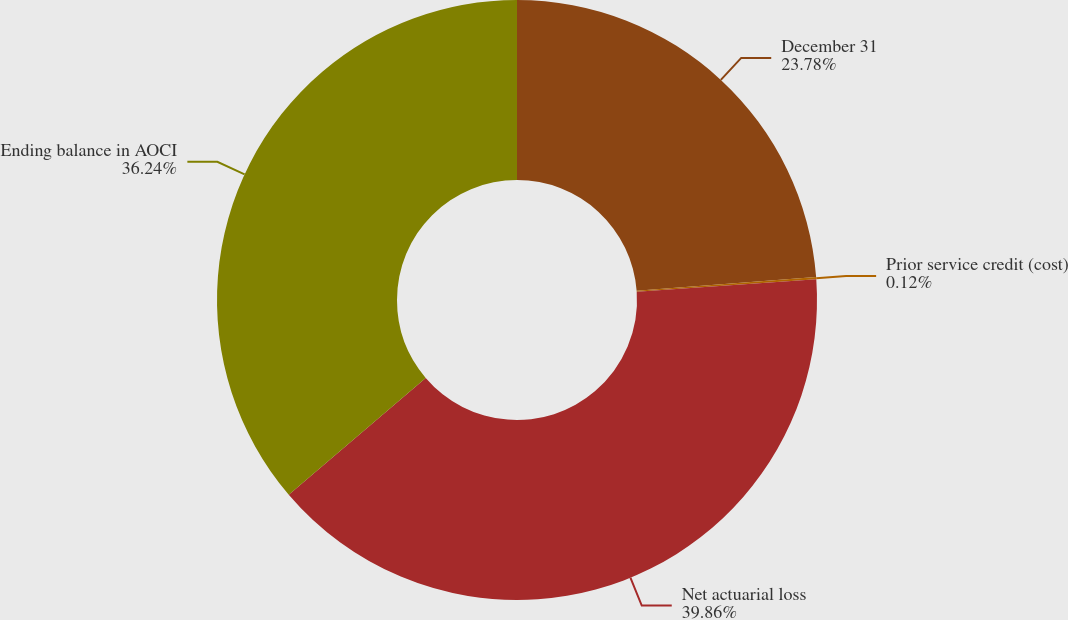Convert chart to OTSL. <chart><loc_0><loc_0><loc_500><loc_500><pie_chart><fcel>December 31<fcel>Prior service credit (cost)<fcel>Net actuarial loss<fcel>Ending balance in AOCI<nl><fcel>23.78%<fcel>0.12%<fcel>39.86%<fcel>36.24%<nl></chart> 